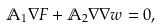Convert formula to latex. <formula><loc_0><loc_0><loc_500><loc_500>\mathbb { A } _ { 1 } \nabla F + \mathbb { A } _ { 2 } \nabla \nabla w = 0 ,</formula> 